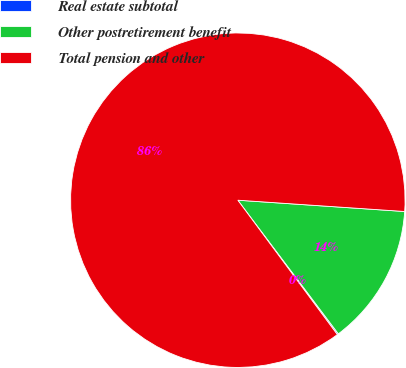Convert chart. <chart><loc_0><loc_0><loc_500><loc_500><pie_chart><fcel>Real estate subtotal<fcel>Other postretirement benefit<fcel>Total pension and other<nl><fcel>0.12%<fcel>13.66%<fcel>86.22%<nl></chart> 